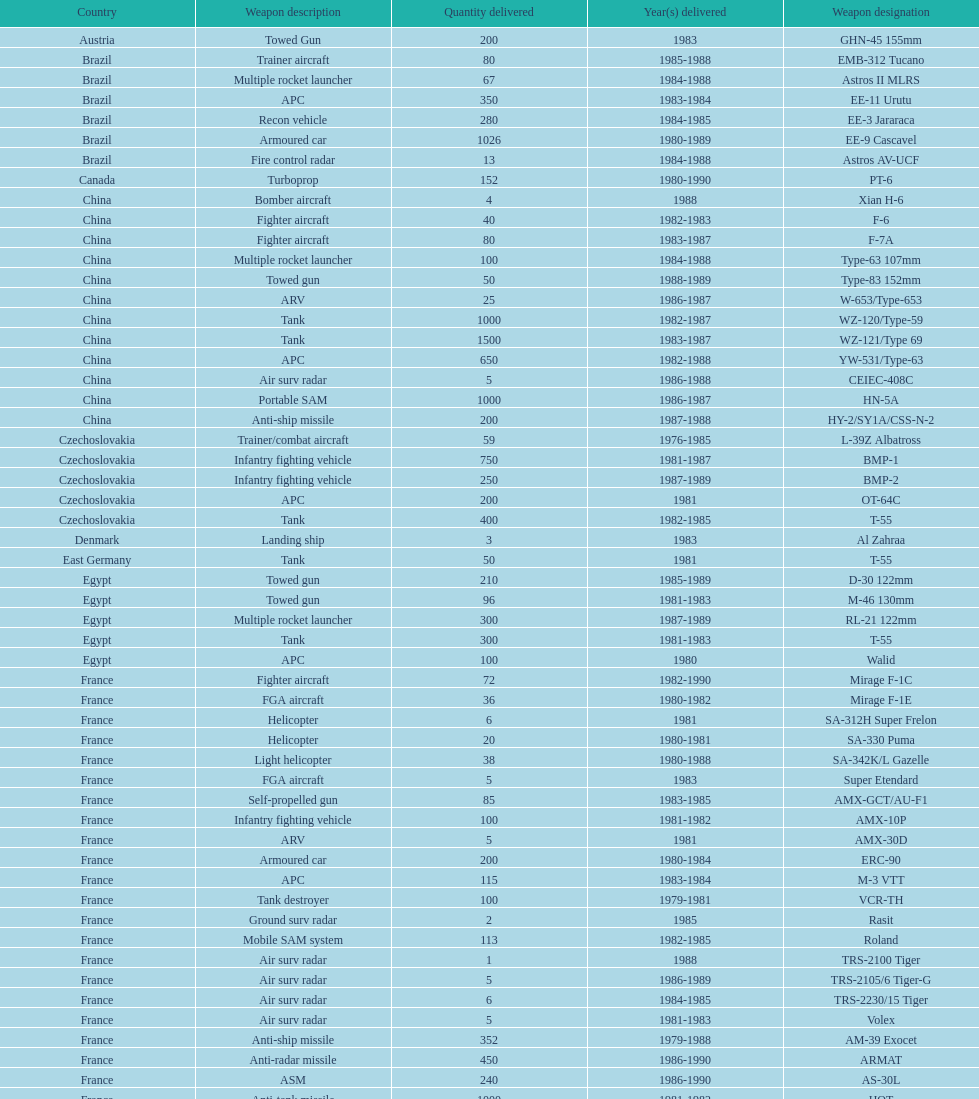Which country had the largest number of towed guns delivered? Soviet Union. 